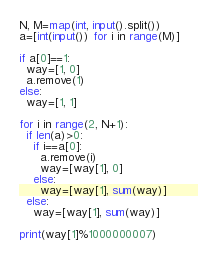Convert code to text. <code><loc_0><loc_0><loc_500><loc_500><_Python_>N, M=map(int, input().split())
a=[int(input()) for i in range(M)]

if a[0]==1:
  way=[1, 0]
  a.remove(1)
else:
  way=[1, 1]
  
for i in range(2, N+1):
  if len(a)>0:
    if i==a[0]:
      a.remove(i)
      way=[way[1], 0]
    else:
      way=[way[1], sum(way)]
  else:
    way=[way[1], sum(way)]
    
print(way[1]%1000000007)</code> 